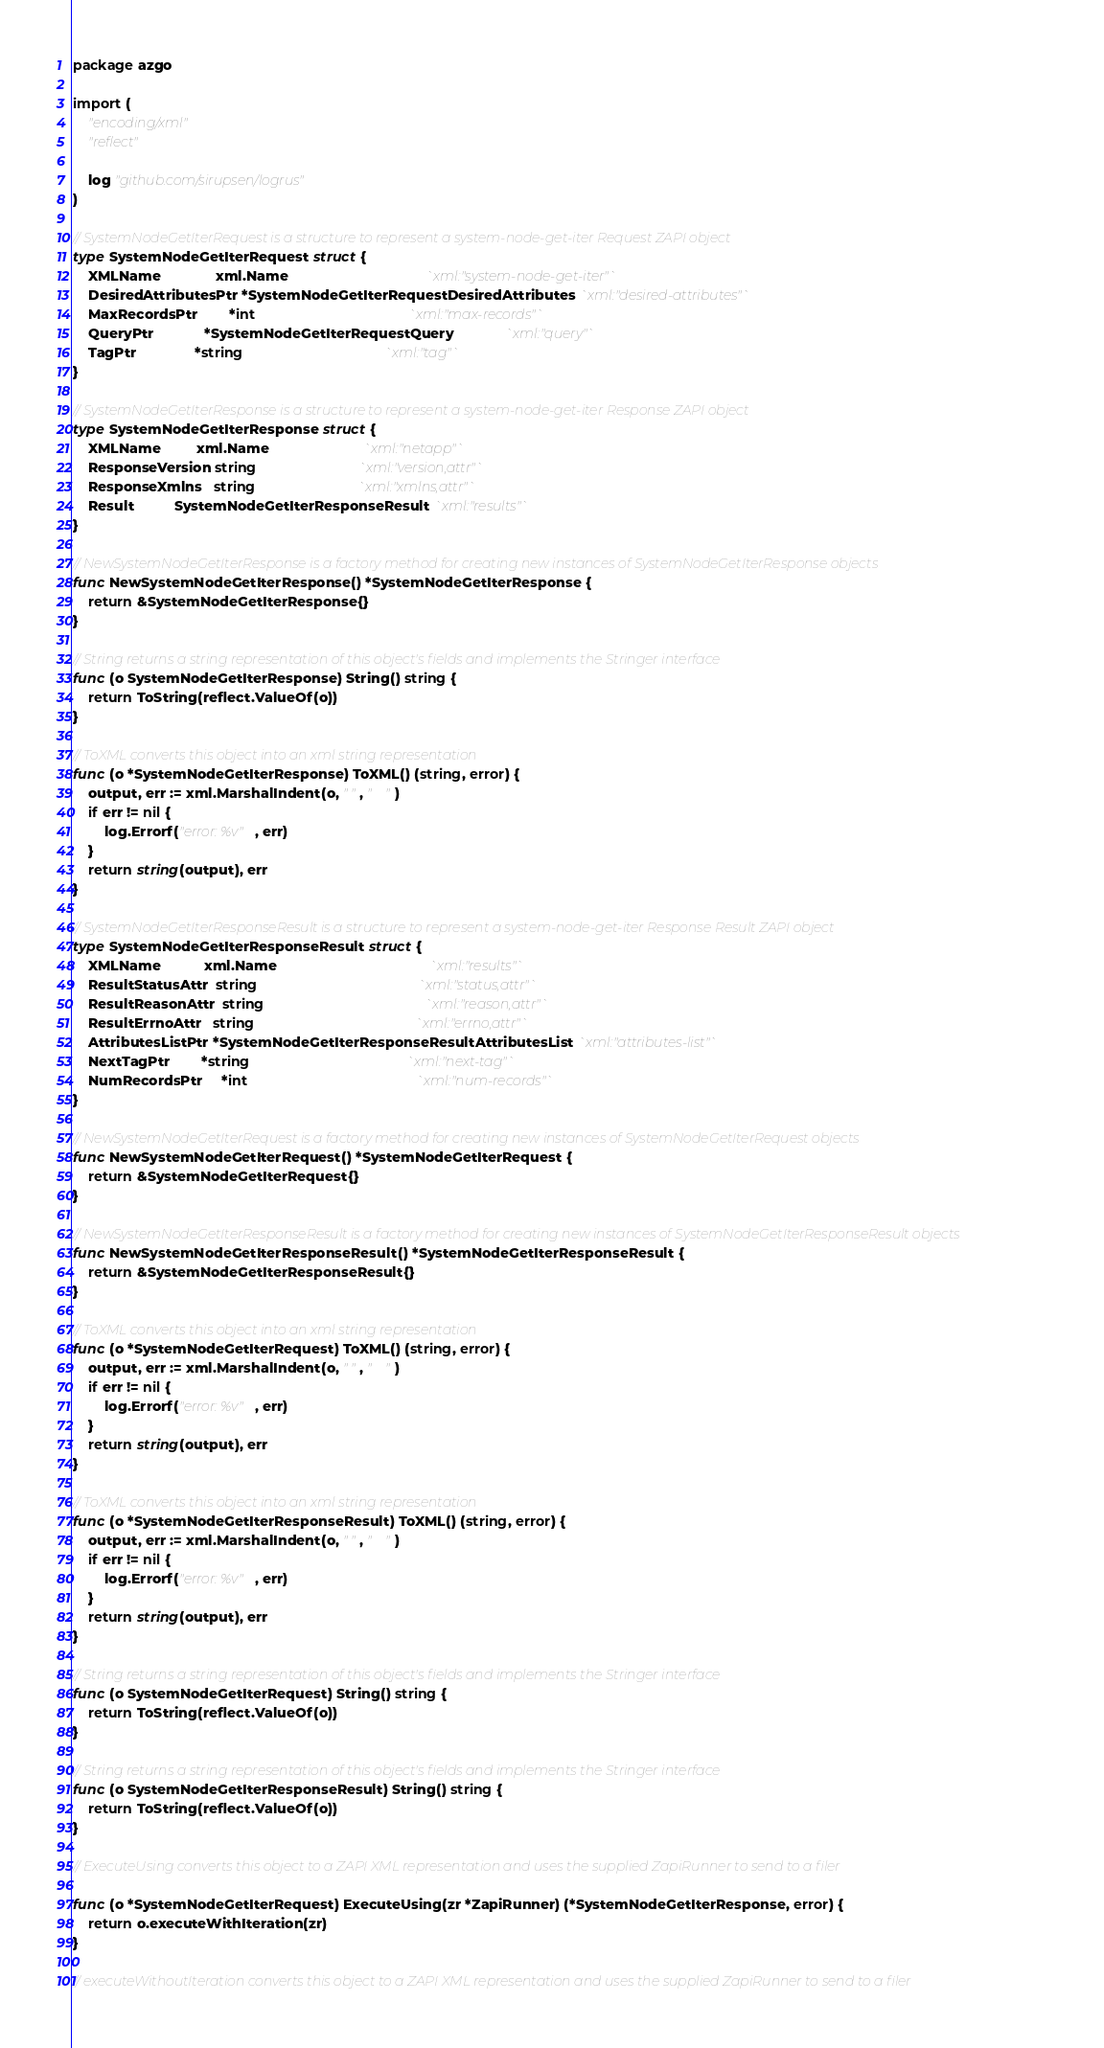Convert code to text. <code><loc_0><loc_0><loc_500><loc_500><_Go_>package azgo

import (
	"encoding/xml"
	"reflect"

	log "github.com/sirupsen/logrus"
)

// SystemNodeGetIterRequest is a structure to represent a system-node-get-iter Request ZAPI object
type SystemNodeGetIterRequest struct {
	XMLName              xml.Name                                   `xml:"system-node-get-iter"`
	DesiredAttributesPtr *SystemNodeGetIterRequestDesiredAttributes `xml:"desired-attributes"`
	MaxRecordsPtr        *int                                       `xml:"max-records"`
	QueryPtr             *SystemNodeGetIterRequestQuery             `xml:"query"`
	TagPtr               *string                                    `xml:"tag"`
}

// SystemNodeGetIterResponse is a structure to represent a system-node-get-iter Response ZAPI object
type SystemNodeGetIterResponse struct {
	XMLName         xml.Name                        `xml:"netapp"`
	ResponseVersion string                          `xml:"version,attr"`
	ResponseXmlns   string                          `xml:"xmlns,attr"`
	Result          SystemNodeGetIterResponseResult `xml:"results"`
}

// NewSystemNodeGetIterResponse is a factory method for creating new instances of SystemNodeGetIterResponse objects
func NewSystemNodeGetIterResponse() *SystemNodeGetIterResponse {
	return &SystemNodeGetIterResponse{}
}

// String returns a string representation of this object's fields and implements the Stringer interface
func (o SystemNodeGetIterResponse) String() string {
	return ToString(reflect.ValueOf(o))
}

// ToXML converts this object into an xml string representation
func (o *SystemNodeGetIterResponse) ToXML() (string, error) {
	output, err := xml.MarshalIndent(o, " ", "    ")
	if err != nil {
		log.Errorf("error: %v", err)
	}
	return string(output), err
}

// SystemNodeGetIterResponseResult is a structure to represent a system-node-get-iter Response Result ZAPI object
type SystemNodeGetIterResponseResult struct {
	XMLName           xml.Name                                       `xml:"results"`
	ResultStatusAttr  string                                         `xml:"status,attr"`
	ResultReasonAttr  string                                         `xml:"reason,attr"`
	ResultErrnoAttr   string                                         `xml:"errno,attr"`
	AttributesListPtr *SystemNodeGetIterResponseResultAttributesList `xml:"attributes-list"`
	NextTagPtr        *string                                        `xml:"next-tag"`
	NumRecordsPtr     *int                                           `xml:"num-records"`
}

// NewSystemNodeGetIterRequest is a factory method for creating new instances of SystemNodeGetIterRequest objects
func NewSystemNodeGetIterRequest() *SystemNodeGetIterRequest {
	return &SystemNodeGetIterRequest{}
}

// NewSystemNodeGetIterResponseResult is a factory method for creating new instances of SystemNodeGetIterResponseResult objects
func NewSystemNodeGetIterResponseResult() *SystemNodeGetIterResponseResult {
	return &SystemNodeGetIterResponseResult{}
}

// ToXML converts this object into an xml string representation
func (o *SystemNodeGetIterRequest) ToXML() (string, error) {
	output, err := xml.MarshalIndent(o, " ", "    ")
	if err != nil {
		log.Errorf("error: %v", err)
	}
	return string(output), err
}

// ToXML converts this object into an xml string representation
func (o *SystemNodeGetIterResponseResult) ToXML() (string, error) {
	output, err := xml.MarshalIndent(o, " ", "    ")
	if err != nil {
		log.Errorf("error: %v", err)
	}
	return string(output), err
}

// String returns a string representation of this object's fields and implements the Stringer interface
func (o SystemNodeGetIterRequest) String() string {
	return ToString(reflect.ValueOf(o))
}

// String returns a string representation of this object's fields and implements the Stringer interface
func (o SystemNodeGetIterResponseResult) String() string {
	return ToString(reflect.ValueOf(o))
}

// ExecuteUsing converts this object to a ZAPI XML representation and uses the supplied ZapiRunner to send to a filer

func (o *SystemNodeGetIterRequest) ExecuteUsing(zr *ZapiRunner) (*SystemNodeGetIterResponse, error) {
	return o.executeWithIteration(zr)
}

// executeWithoutIteration converts this object to a ZAPI XML representation and uses the supplied ZapiRunner to send to a filer
</code> 